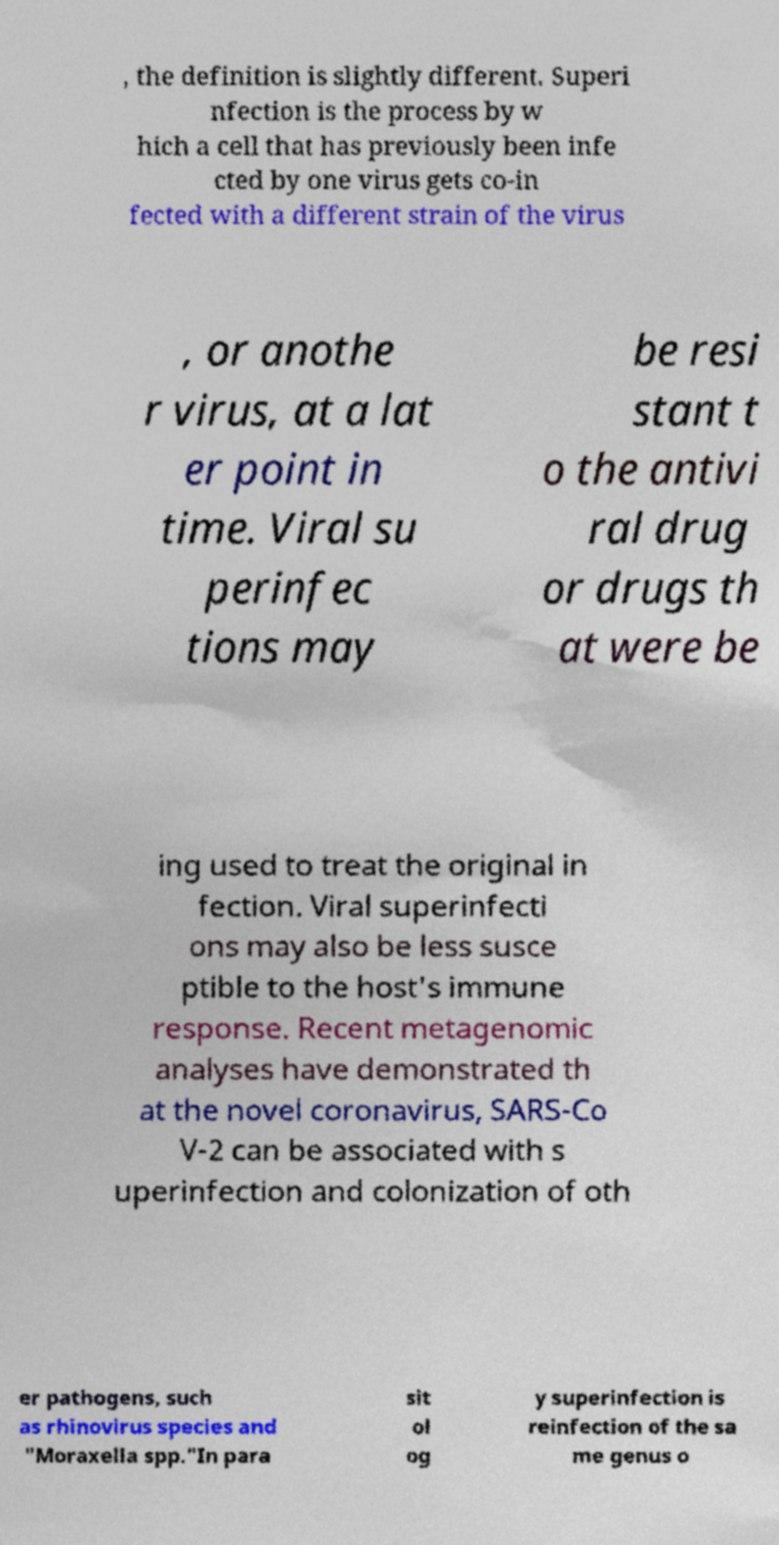Please read and relay the text visible in this image. What does it say? , the definition is slightly different. Superi nfection is the process by w hich a cell that has previously been infe cted by one virus gets co-in fected with a different strain of the virus , or anothe r virus, at a lat er point in time. Viral su perinfec tions may be resi stant t o the antivi ral drug or drugs th at were be ing used to treat the original in fection. Viral superinfecti ons may also be less susce ptible to the host's immune response. Recent metagenomic analyses have demonstrated th at the novel coronavirus, SARS-Co V-2 can be associated with s uperinfection and colonization of oth er pathogens, such as rhinovirus species and "Moraxella spp."In para sit ol og y superinfection is reinfection of the sa me genus o 